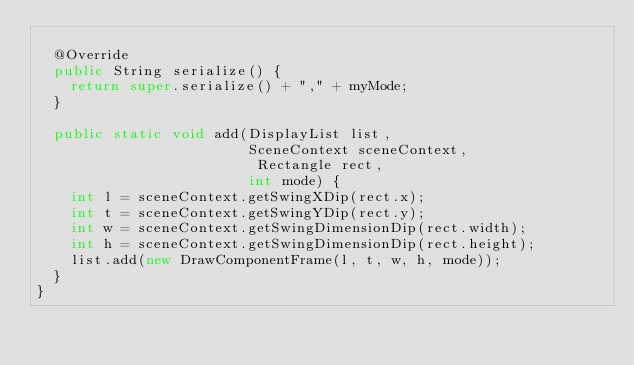<code> <loc_0><loc_0><loc_500><loc_500><_Java_>
  @Override
  public String serialize() {
    return super.serialize() + "," + myMode;
  }

  public static void add(DisplayList list,
                         SceneContext sceneContext,
                          Rectangle rect,
                         int mode) {
    int l = sceneContext.getSwingXDip(rect.x);
    int t = sceneContext.getSwingYDip(rect.y);
    int w = sceneContext.getSwingDimensionDip(rect.width);
    int h = sceneContext.getSwingDimensionDip(rect.height);
    list.add(new DrawComponentFrame(l, t, w, h, mode));
  }
}
</code> 